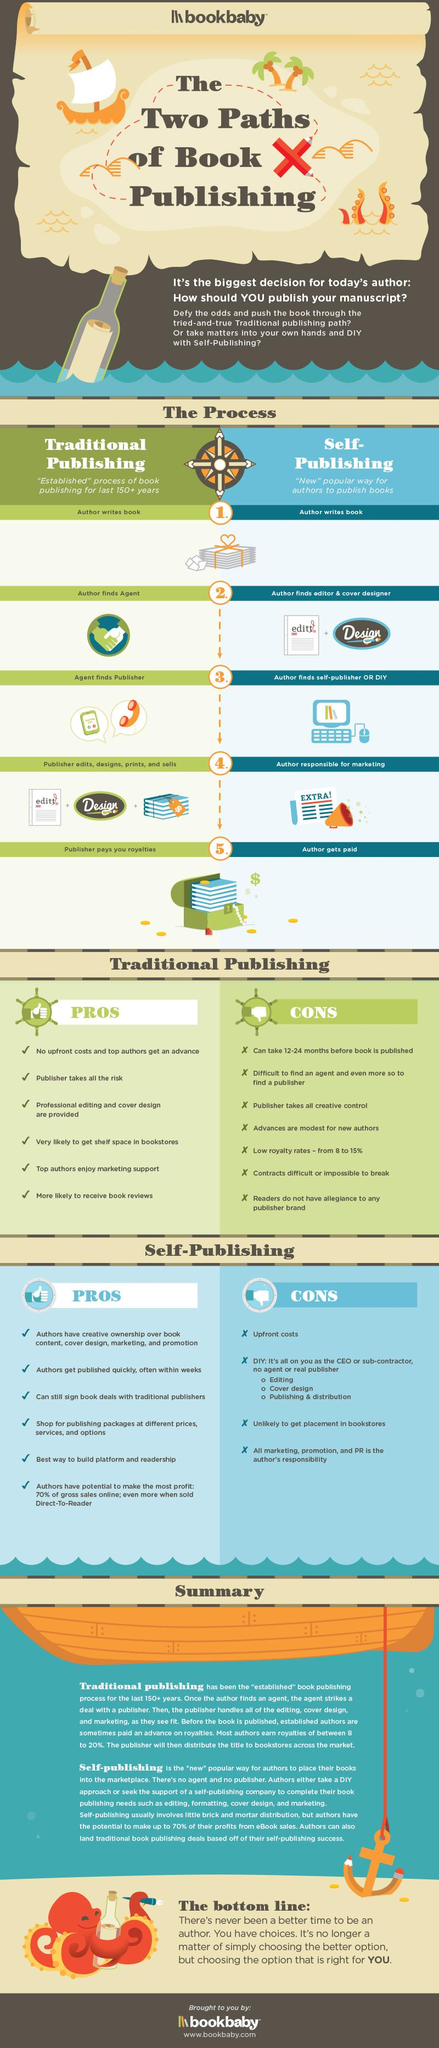Outline some significant characteristics in this image. There are two processes in publishing: traditional publishing and self-publishing. Self-publishing is the best publishing process for quickly publishing a book. The process in which the Agent discovers the Publisher is through traditional publishing. In both traditional publishing and self-publishing, the first step in the process is for the author to write the book. Traditional publishing involves a risk for the publisher. 